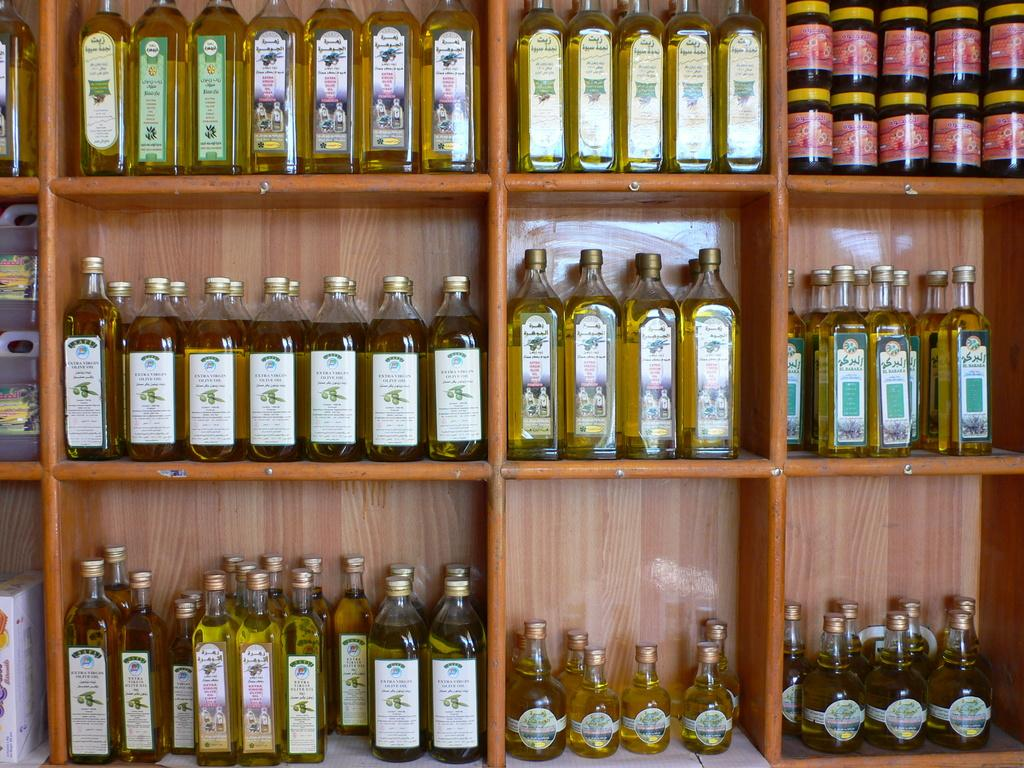What type of furniture is present in the image? There is a shelf in the image. What feature does the shelf have? The shelf has racks. What items are placed on the racks? There are bottles on the racks. How do the bottles differ from one another? The bottles have different shapes and sizes. How does the shelf contribute to the parcel delivery process in the image? There is no mention of a parcel delivery process in the image; it only shows a shelf with racks and bottles. 